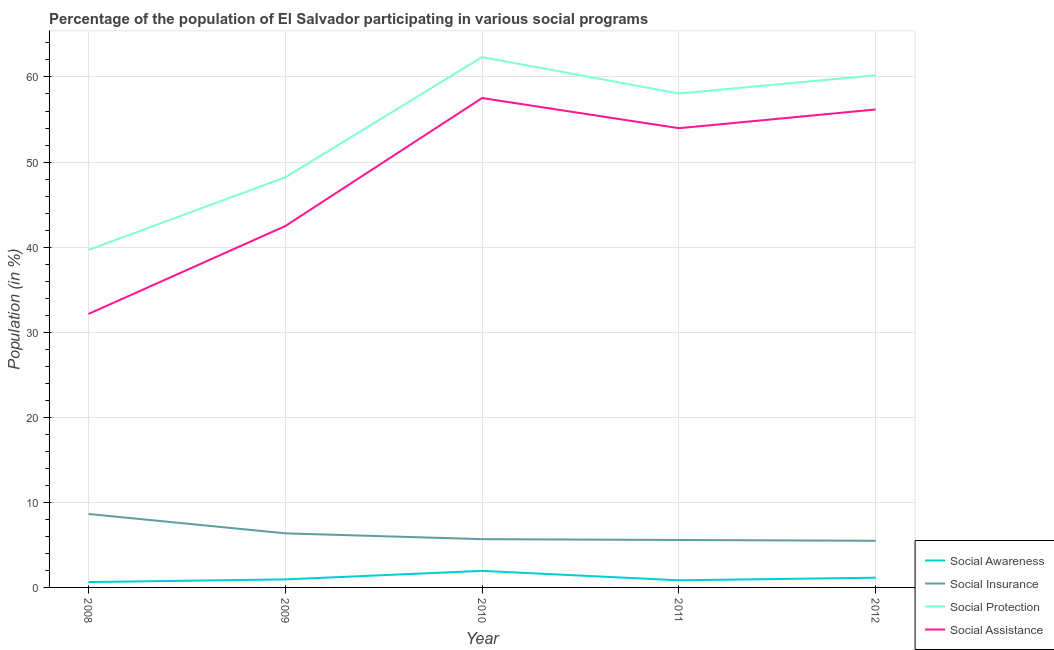Is the number of lines equal to the number of legend labels?
Keep it short and to the point. Yes. What is the participation of population in social assistance programs in 2012?
Offer a terse response. 56.18. Across all years, what is the maximum participation of population in social insurance programs?
Keep it short and to the point. 8.63. Across all years, what is the minimum participation of population in social awareness programs?
Your answer should be very brief. 0.63. In which year was the participation of population in social awareness programs maximum?
Make the answer very short. 2010. What is the total participation of population in social insurance programs in the graph?
Give a very brief answer. 31.72. What is the difference between the participation of population in social awareness programs in 2010 and that in 2011?
Offer a very short reply. 1.11. What is the difference between the participation of population in social insurance programs in 2011 and the participation of population in social protection programs in 2008?
Offer a terse response. -34.09. What is the average participation of population in social awareness programs per year?
Keep it short and to the point. 1.1. In the year 2010, what is the difference between the participation of population in social insurance programs and participation of population in social assistance programs?
Give a very brief answer. -51.85. In how many years, is the participation of population in social insurance programs greater than 8 %?
Make the answer very short. 1. What is the ratio of the participation of population in social insurance programs in 2009 to that in 2011?
Offer a terse response. 1.14. Is the participation of population in social awareness programs in 2009 less than that in 2012?
Ensure brevity in your answer.  Yes. Is the difference between the participation of population in social assistance programs in 2011 and 2012 greater than the difference between the participation of population in social insurance programs in 2011 and 2012?
Your answer should be very brief. No. What is the difference between the highest and the second highest participation of population in social awareness programs?
Provide a short and direct response. 0.8. What is the difference between the highest and the lowest participation of population in social protection programs?
Offer a very short reply. 22.67. In how many years, is the participation of population in social protection programs greater than the average participation of population in social protection programs taken over all years?
Provide a short and direct response. 3. Is it the case that in every year, the sum of the participation of population in social assistance programs and participation of population in social awareness programs is greater than the sum of participation of population in social protection programs and participation of population in social insurance programs?
Offer a very short reply. Yes. Does the participation of population in social assistance programs monotonically increase over the years?
Ensure brevity in your answer.  No. Does the graph contain grids?
Give a very brief answer. Yes. Where does the legend appear in the graph?
Your response must be concise. Bottom right. What is the title of the graph?
Give a very brief answer. Percentage of the population of El Salvador participating in various social programs . What is the label or title of the X-axis?
Offer a very short reply. Year. What is the Population (in %) in Social Awareness in 2008?
Your response must be concise. 0.63. What is the Population (in %) in Social Insurance in 2008?
Your response must be concise. 8.63. What is the Population (in %) in Social Protection in 2008?
Your response must be concise. 39.67. What is the Population (in %) of Social Assistance in 2008?
Provide a short and direct response. 32.15. What is the Population (in %) in Social Awareness in 2009?
Your answer should be compact. 0.95. What is the Population (in %) in Social Insurance in 2009?
Give a very brief answer. 6.36. What is the Population (in %) of Social Protection in 2009?
Make the answer very short. 48.2. What is the Population (in %) of Social Assistance in 2009?
Your response must be concise. 42.48. What is the Population (in %) of Social Awareness in 2010?
Give a very brief answer. 1.95. What is the Population (in %) of Social Insurance in 2010?
Offer a terse response. 5.67. What is the Population (in %) of Social Protection in 2010?
Give a very brief answer. 62.34. What is the Population (in %) in Social Assistance in 2010?
Make the answer very short. 57.53. What is the Population (in %) of Social Awareness in 2011?
Make the answer very short. 0.84. What is the Population (in %) in Social Insurance in 2011?
Give a very brief answer. 5.58. What is the Population (in %) of Social Protection in 2011?
Keep it short and to the point. 58.06. What is the Population (in %) in Social Assistance in 2011?
Offer a terse response. 53.98. What is the Population (in %) in Social Awareness in 2012?
Make the answer very short. 1.14. What is the Population (in %) of Social Insurance in 2012?
Provide a short and direct response. 5.48. What is the Population (in %) in Social Protection in 2012?
Provide a short and direct response. 60.19. What is the Population (in %) of Social Assistance in 2012?
Give a very brief answer. 56.18. Across all years, what is the maximum Population (in %) in Social Awareness?
Ensure brevity in your answer.  1.95. Across all years, what is the maximum Population (in %) in Social Insurance?
Keep it short and to the point. 8.63. Across all years, what is the maximum Population (in %) in Social Protection?
Your answer should be compact. 62.34. Across all years, what is the maximum Population (in %) of Social Assistance?
Ensure brevity in your answer.  57.53. Across all years, what is the minimum Population (in %) in Social Awareness?
Offer a very short reply. 0.63. Across all years, what is the minimum Population (in %) of Social Insurance?
Your answer should be compact. 5.48. Across all years, what is the minimum Population (in %) in Social Protection?
Provide a succinct answer. 39.67. Across all years, what is the minimum Population (in %) of Social Assistance?
Provide a short and direct response. 32.15. What is the total Population (in %) in Social Awareness in the graph?
Keep it short and to the point. 5.5. What is the total Population (in %) of Social Insurance in the graph?
Ensure brevity in your answer.  31.72. What is the total Population (in %) of Social Protection in the graph?
Your answer should be very brief. 268.46. What is the total Population (in %) of Social Assistance in the graph?
Offer a very short reply. 242.31. What is the difference between the Population (in %) in Social Awareness in 2008 and that in 2009?
Provide a succinct answer. -0.32. What is the difference between the Population (in %) in Social Insurance in 2008 and that in 2009?
Make the answer very short. 2.28. What is the difference between the Population (in %) of Social Protection in 2008 and that in 2009?
Provide a succinct answer. -8.53. What is the difference between the Population (in %) of Social Assistance in 2008 and that in 2009?
Offer a terse response. -10.33. What is the difference between the Population (in %) in Social Awareness in 2008 and that in 2010?
Offer a very short reply. -1.32. What is the difference between the Population (in %) in Social Insurance in 2008 and that in 2010?
Make the answer very short. 2.96. What is the difference between the Population (in %) of Social Protection in 2008 and that in 2010?
Ensure brevity in your answer.  -22.67. What is the difference between the Population (in %) of Social Assistance in 2008 and that in 2010?
Your response must be concise. -25.38. What is the difference between the Population (in %) in Social Awareness in 2008 and that in 2011?
Keep it short and to the point. -0.21. What is the difference between the Population (in %) of Social Insurance in 2008 and that in 2011?
Your answer should be very brief. 3.06. What is the difference between the Population (in %) in Social Protection in 2008 and that in 2011?
Your answer should be very brief. -18.39. What is the difference between the Population (in %) of Social Assistance in 2008 and that in 2011?
Your answer should be very brief. -21.83. What is the difference between the Population (in %) in Social Awareness in 2008 and that in 2012?
Your response must be concise. -0.51. What is the difference between the Population (in %) of Social Insurance in 2008 and that in 2012?
Your answer should be very brief. 3.15. What is the difference between the Population (in %) in Social Protection in 2008 and that in 2012?
Provide a short and direct response. -20.53. What is the difference between the Population (in %) of Social Assistance in 2008 and that in 2012?
Your answer should be compact. -24.03. What is the difference between the Population (in %) in Social Awareness in 2009 and that in 2010?
Your answer should be compact. -1. What is the difference between the Population (in %) in Social Insurance in 2009 and that in 2010?
Your answer should be very brief. 0.68. What is the difference between the Population (in %) of Social Protection in 2009 and that in 2010?
Provide a short and direct response. -14.14. What is the difference between the Population (in %) in Social Assistance in 2009 and that in 2010?
Your answer should be very brief. -15.05. What is the difference between the Population (in %) of Social Awareness in 2009 and that in 2011?
Provide a succinct answer. 0.11. What is the difference between the Population (in %) of Social Insurance in 2009 and that in 2011?
Your answer should be compact. 0.78. What is the difference between the Population (in %) of Social Protection in 2009 and that in 2011?
Give a very brief answer. -9.86. What is the difference between the Population (in %) of Social Assistance in 2009 and that in 2011?
Your answer should be very brief. -11.5. What is the difference between the Population (in %) in Social Awareness in 2009 and that in 2012?
Provide a succinct answer. -0.2. What is the difference between the Population (in %) in Social Insurance in 2009 and that in 2012?
Offer a very short reply. 0.88. What is the difference between the Population (in %) in Social Protection in 2009 and that in 2012?
Keep it short and to the point. -11.99. What is the difference between the Population (in %) in Social Assistance in 2009 and that in 2012?
Provide a short and direct response. -13.7. What is the difference between the Population (in %) in Social Awareness in 2010 and that in 2011?
Your answer should be very brief. 1.11. What is the difference between the Population (in %) in Social Insurance in 2010 and that in 2011?
Make the answer very short. 0.1. What is the difference between the Population (in %) of Social Protection in 2010 and that in 2011?
Make the answer very short. 4.28. What is the difference between the Population (in %) of Social Assistance in 2010 and that in 2011?
Your response must be concise. 3.55. What is the difference between the Population (in %) in Social Awareness in 2010 and that in 2012?
Provide a short and direct response. 0.8. What is the difference between the Population (in %) of Social Insurance in 2010 and that in 2012?
Provide a succinct answer. 0.19. What is the difference between the Population (in %) of Social Protection in 2010 and that in 2012?
Provide a short and direct response. 2.15. What is the difference between the Population (in %) of Social Assistance in 2010 and that in 2012?
Provide a succinct answer. 1.34. What is the difference between the Population (in %) of Social Awareness in 2011 and that in 2012?
Give a very brief answer. -0.3. What is the difference between the Population (in %) of Social Insurance in 2011 and that in 2012?
Your answer should be compact. 0.09. What is the difference between the Population (in %) in Social Protection in 2011 and that in 2012?
Your answer should be compact. -2.14. What is the difference between the Population (in %) of Social Assistance in 2011 and that in 2012?
Keep it short and to the point. -2.2. What is the difference between the Population (in %) in Social Awareness in 2008 and the Population (in %) in Social Insurance in 2009?
Keep it short and to the point. -5.73. What is the difference between the Population (in %) in Social Awareness in 2008 and the Population (in %) in Social Protection in 2009?
Your answer should be very brief. -47.57. What is the difference between the Population (in %) in Social Awareness in 2008 and the Population (in %) in Social Assistance in 2009?
Provide a succinct answer. -41.85. What is the difference between the Population (in %) in Social Insurance in 2008 and the Population (in %) in Social Protection in 2009?
Your answer should be very brief. -39.57. What is the difference between the Population (in %) of Social Insurance in 2008 and the Population (in %) of Social Assistance in 2009?
Make the answer very short. -33.84. What is the difference between the Population (in %) in Social Protection in 2008 and the Population (in %) in Social Assistance in 2009?
Give a very brief answer. -2.81. What is the difference between the Population (in %) in Social Awareness in 2008 and the Population (in %) in Social Insurance in 2010?
Ensure brevity in your answer.  -5.04. What is the difference between the Population (in %) of Social Awareness in 2008 and the Population (in %) of Social Protection in 2010?
Ensure brevity in your answer.  -61.71. What is the difference between the Population (in %) in Social Awareness in 2008 and the Population (in %) in Social Assistance in 2010?
Ensure brevity in your answer.  -56.9. What is the difference between the Population (in %) in Social Insurance in 2008 and the Population (in %) in Social Protection in 2010?
Your answer should be compact. -53.71. What is the difference between the Population (in %) of Social Insurance in 2008 and the Population (in %) of Social Assistance in 2010?
Offer a very short reply. -48.89. What is the difference between the Population (in %) in Social Protection in 2008 and the Population (in %) in Social Assistance in 2010?
Provide a succinct answer. -17.86. What is the difference between the Population (in %) in Social Awareness in 2008 and the Population (in %) in Social Insurance in 2011?
Provide a succinct answer. -4.95. What is the difference between the Population (in %) in Social Awareness in 2008 and the Population (in %) in Social Protection in 2011?
Ensure brevity in your answer.  -57.43. What is the difference between the Population (in %) in Social Awareness in 2008 and the Population (in %) in Social Assistance in 2011?
Offer a terse response. -53.35. What is the difference between the Population (in %) in Social Insurance in 2008 and the Population (in %) in Social Protection in 2011?
Your answer should be compact. -49.42. What is the difference between the Population (in %) in Social Insurance in 2008 and the Population (in %) in Social Assistance in 2011?
Your answer should be very brief. -45.34. What is the difference between the Population (in %) of Social Protection in 2008 and the Population (in %) of Social Assistance in 2011?
Your answer should be compact. -14.31. What is the difference between the Population (in %) of Social Awareness in 2008 and the Population (in %) of Social Insurance in 2012?
Provide a succinct answer. -4.85. What is the difference between the Population (in %) of Social Awareness in 2008 and the Population (in %) of Social Protection in 2012?
Keep it short and to the point. -59.57. What is the difference between the Population (in %) of Social Awareness in 2008 and the Population (in %) of Social Assistance in 2012?
Provide a short and direct response. -55.55. What is the difference between the Population (in %) of Social Insurance in 2008 and the Population (in %) of Social Protection in 2012?
Make the answer very short. -51.56. What is the difference between the Population (in %) in Social Insurance in 2008 and the Population (in %) in Social Assistance in 2012?
Offer a terse response. -47.55. What is the difference between the Population (in %) in Social Protection in 2008 and the Population (in %) in Social Assistance in 2012?
Provide a succinct answer. -16.51. What is the difference between the Population (in %) in Social Awareness in 2009 and the Population (in %) in Social Insurance in 2010?
Keep it short and to the point. -4.73. What is the difference between the Population (in %) in Social Awareness in 2009 and the Population (in %) in Social Protection in 2010?
Provide a succinct answer. -61.4. What is the difference between the Population (in %) of Social Awareness in 2009 and the Population (in %) of Social Assistance in 2010?
Make the answer very short. -56.58. What is the difference between the Population (in %) of Social Insurance in 2009 and the Population (in %) of Social Protection in 2010?
Offer a terse response. -55.98. What is the difference between the Population (in %) of Social Insurance in 2009 and the Population (in %) of Social Assistance in 2010?
Provide a succinct answer. -51.17. What is the difference between the Population (in %) in Social Protection in 2009 and the Population (in %) in Social Assistance in 2010?
Your response must be concise. -9.32. What is the difference between the Population (in %) in Social Awareness in 2009 and the Population (in %) in Social Insurance in 2011?
Provide a succinct answer. -4.63. What is the difference between the Population (in %) in Social Awareness in 2009 and the Population (in %) in Social Protection in 2011?
Your response must be concise. -57.11. What is the difference between the Population (in %) of Social Awareness in 2009 and the Population (in %) of Social Assistance in 2011?
Ensure brevity in your answer.  -53.03. What is the difference between the Population (in %) of Social Insurance in 2009 and the Population (in %) of Social Protection in 2011?
Make the answer very short. -51.7. What is the difference between the Population (in %) in Social Insurance in 2009 and the Population (in %) in Social Assistance in 2011?
Your response must be concise. -47.62. What is the difference between the Population (in %) in Social Protection in 2009 and the Population (in %) in Social Assistance in 2011?
Make the answer very short. -5.78. What is the difference between the Population (in %) in Social Awareness in 2009 and the Population (in %) in Social Insurance in 2012?
Provide a short and direct response. -4.54. What is the difference between the Population (in %) of Social Awareness in 2009 and the Population (in %) of Social Protection in 2012?
Make the answer very short. -59.25. What is the difference between the Population (in %) in Social Awareness in 2009 and the Population (in %) in Social Assistance in 2012?
Offer a very short reply. -55.24. What is the difference between the Population (in %) in Social Insurance in 2009 and the Population (in %) in Social Protection in 2012?
Your answer should be compact. -53.84. What is the difference between the Population (in %) of Social Insurance in 2009 and the Population (in %) of Social Assistance in 2012?
Make the answer very short. -49.82. What is the difference between the Population (in %) in Social Protection in 2009 and the Population (in %) in Social Assistance in 2012?
Make the answer very short. -7.98. What is the difference between the Population (in %) of Social Awareness in 2010 and the Population (in %) of Social Insurance in 2011?
Provide a short and direct response. -3.63. What is the difference between the Population (in %) of Social Awareness in 2010 and the Population (in %) of Social Protection in 2011?
Make the answer very short. -56.11. What is the difference between the Population (in %) of Social Awareness in 2010 and the Population (in %) of Social Assistance in 2011?
Keep it short and to the point. -52.03. What is the difference between the Population (in %) of Social Insurance in 2010 and the Population (in %) of Social Protection in 2011?
Ensure brevity in your answer.  -52.38. What is the difference between the Population (in %) in Social Insurance in 2010 and the Population (in %) in Social Assistance in 2011?
Your answer should be compact. -48.31. What is the difference between the Population (in %) in Social Protection in 2010 and the Population (in %) in Social Assistance in 2011?
Your answer should be very brief. 8.36. What is the difference between the Population (in %) of Social Awareness in 2010 and the Population (in %) of Social Insurance in 2012?
Provide a short and direct response. -3.54. What is the difference between the Population (in %) in Social Awareness in 2010 and the Population (in %) in Social Protection in 2012?
Make the answer very short. -58.25. What is the difference between the Population (in %) of Social Awareness in 2010 and the Population (in %) of Social Assistance in 2012?
Make the answer very short. -54.24. What is the difference between the Population (in %) of Social Insurance in 2010 and the Population (in %) of Social Protection in 2012?
Make the answer very short. -54.52. What is the difference between the Population (in %) in Social Insurance in 2010 and the Population (in %) in Social Assistance in 2012?
Make the answer very short. -50.51. What is the difference between the Population (in %) in Social Protection in 2010 and the Population (in %) in Social Assistance in 2012?
Offer a terse response. 6.16. What is the difference between the Population (in %) in Social Awareness in 2011 and the Population (in %) in Social Insurance in 2012?
Provide a succinct answer. -4.65. What is the difference between the Population (in %) of Social Awareness in 2011 and the Population (in %) of Social Protection in 2012?
Make the answer very short. -59.36. What is the difference between the Population (in %) of Social Awareness in 2011 and the Population (in %) of Social Assistance in 2012?
Provide a short and direct response. -55.34. What is the difference between the Population (in %) of Social Insurance in 2011 and the Population (in %) of Social Protection in 2012?
Make the answer very short. -54.62. What is the difference between the Population (in %) of Social Insurance in 2011 and the Population (in %) of Social Assistance in 2012?
Provide a succinct answer. -50.6. What is the difference between the Population (in %) in Social Protection in 2011 and the Population (in %) in Social Assistance in 2012?
Make the answer very short. 1.88. What is the average Population (in %) in Social Awareness per year?
Keep it short and to the point. 1.1. What is the average Population (in %) of Social Insurance per year?
Provide a short and direct response. 6.34. What is the average Population (in %) in Social Protection per year?
Ensure brevity in your answer.  53.69. What is the average Population (in %) of Social Assistance per year?
Offer a terse response. 48.46. In the year 2008, what is the difference between the Population (in %) of Social Awareness and Population (in %) of Social Insurance?
Ensure brevity in your answer.  -8.01. In the year 2008, what is the difference between the Population (in %) in Social Awareness and Population (in %) in Social Protection?
Offer a terse response. -39.04. In the year 2008, what is the difference between the Population (in %) in Social Awareness and Population (in %) in Social Assistance?
Make the answer very short. -31.52. In the year 2008, what is the difference between the Population (in %) in Social Insurance and Population (in %) in Social Protection?
Your response must be concise. -31.03. In the year 2008, what is the difference between the Population (in %) of Social Insurance and Population (in %) of Social Assistance?
Your answer should be very brief. -23.51. In the year 2008, what is the difference between the Population (in %) in Social Protection and Population (in %) in Social Assistance?
Your response must be concise. 7.52. In the year 2009, what is the difference between the Population (in %) in Social Awareness and Population (in %) in Social Insurance?
Make the answer very short. -5.41. In the year 2009, what is the difference between the Population (in %) in Social Awareness and Population (in %) in Social Protection?
Keep it short and to the point. -47.26. In the year 2009, what is the difference between the Population (in %) of Social Awareness and Population (in %) of Social Assistance?
Keep it short and to the point. -41.53. In the year 2009, what is the difference between the Population (in %) in Social Insurance and Population (in %) in Social Protection?
Your answer should be compact. -41.84. In the year 2009, what is the difference between the Population (in %) in Social Insurance and Population (in %) in Social Assistance?
Your answer should be very brief. -36.12. In the year 2009, what is the difference between the Population (in %) in Social Protection and Population (in %) in Social Assistance?
Your answer should be compact. 5.72. In the year 2010, what is the difference between the Population (in %) in Social Awareness and Population (in %) in Social Insurance?
Offer a terse response. -3.73. In the year 2010, what is the difference between the Population (in %) of Social Awareness and Population (in %) of Social Protection?
Keep it short and to the point. -60.39. In the year 2010, what is the difference between the Population (in %) in Social Awareness and Population (in %) in Social Assistance?
Offer a very short reply. -55.58. In the year 2010, what is the difference between the Population (in %) in Social Insurance and Population (in %) in Social Protection?
Your answer should be compact. -56.67. In the year 2010, what is the difference between the Population (in %) of Social Insurance and Population (in %) of Social Assistance?
Your answer should be compact. -51.85. In the year 2010, what is the difference between the Population (in %) in Social Protection and Population (in %) in Social Assistance?
Give a very brief answer. 4.82. In the year 2011, what is the difference between the Population (in %) in Social Awareness and Population (in %) in Social Insurance?
Provide a short and direct response. -4.74. In the year 2011, what is the difference between the Population (in %) in Social Awareness and Population (in %) in Social Protection?
Provide a succinct answer. -57.22. In the year 2011, what is the difference between the Population (in %) of Social Awareness and Population (in %) of Social Assistance?
Ensure brevity in your answer.  -53.14. In the year 2011, what is the difference between the Population (in %) of Social Insurance and Population (in %) of Social Protection?
Give a very brief answer. -52.48. In the year 2011, what is the difference between the Population (in %) of Social Insurance and Population (in %) of Social Assistance?
Make the answer very short. -48.4. In the year 2011, what is the difference between the Population (in %) of Social Protection and Population (in %) of Social Assistance?
Your answer should be compact. 4.08. In the year 2012, what is the difference between the Population (in %) of Social Awareness and Population (in %) of Social Insurance?
Ensure brevity in your answer.  -4.34. In the year 2012, what is the difference between the Population (in %) of Social Awareness and Population (in %) of Social Protection?
Your answer should be compact. -59.05. In the year 2012, what is the difference between the Population (in %) in Social Awareness and Population (in %) in Social Assistance?
Offer a very short reply. -55.04. In the year 2012, what is the difference between the Population (in %) of Social Insurance and Population (in %) of Social Protection?
Your answer should be very brief. -54.71. In the year 2012, what is the difference between the Population (in %) of Social Insurance and Population (in %) of Social Assistance?
Offer a very short reply. -50.7. In the year 2012, what is the difference between the Population (in %) in Social Protection and Population (in %) in Social Assistance?
Ensure brevity in your answer.  4.01. What is the ratio of the Population (in %) in Social Awareness in 2008 to that in 2009?
Your answer should be compact. 0.67. What is the ratio of the Population (in %) in Social Insurance in 2008 to that in 2009?
Your answer should be compact. 1.36. What is the ratio of the Population (in %) in Social Protection in 2008 to that in 2009?
Ensure brevity in your answer.  0.82. What is the ratio of the Population (in %) of Social Assistance in 2008 to that in 2009?
Your answer should be very brief. 0.76. What is the ratio of the Population (in %) in Social Awareness in 2008 to that in 2010?
Provide a short and direct response. 0.32. What is the ratio of the Population (in %) in Social Insurance in 2008 to that in 2010?
Give a very brief answer. 1.52. What is the ratio of the Population (in %) of Social Protection in 2008 to that in 2010?
Ensure brevity in your answer.  0.64. What is the ratio of the Population (in %) of Social Assistance in 2008 to that in 2010?
Give a very brief answer. 0.56. What is the ratio of the Population (in %) of Social Awareness in 2008 to that in 2011?
Your answer should be compact. 0.75. What is the ratio of the Population (in %) of Social Insurance in 2008 to that in 2011?
Provide a short and direct response. 1.55. What is the ratio of the Population (in %) in Social Protection in 2008 to that in 2011?
Make the answer very short. 0.68. What is the ratio of the Population (in %) in Social Assistance in 2008 to that in 2011?
Ensure brevity in your answer.  0.6. What is the ratio of the Population (in %) of Social Awareness in 2008 to that in 2012?
Your answer should be very brief. 0.55. What is the ratio of the Population (in %) in Social Insurance in 2008 to that in 2012?
Provide a succinct answer. 1.57. What is the ratio of the Population (in %) of Social Protection in 2008 to that in 2012?
Provide a short and direct response. 0.66. What is the ratio of the Population (in %) in Social Assistance in 2008 to that in 2012?
Your answer should be very brief. 0.57. What is the ratio of the Population (in %) of Social Awareness in 2009 to that in 2010?
Provide a succinct answer. 0.49. What is the ratio of the Population (in %) in Social Insurance in 2009 to that in 2010?
Make the answer very short. 1.12. What is the ratio of the Population (in %) of Social Protection in 2009 to that in 2010?
Your answer should be compact. 0.77. What is the ratio of the Population (in %) of Social Assistance in 2009 to that in 2010?
Provide a short and direct response. 0.74. What is the ratio of the Population (in %) of Social Awareness in 2009 to that in 2011?
Provide a succinct answer. 1.13. What is the ratio of the Population (in %) in Social Insurance in 2009 to that in 2011?
Ensure brevity in your answer.  1.14. What is the ratio of the Population (in %) of Social Protection in 2009 to that in 2011?
Your response must be concise. 0.83. What is the ratio of the Population (in %) in Social Assistance in 2009 to that in 2011?
Your response must be concise. 0.79. What is the ratio of the Population (in %) in Social Awareness in 2009 to that in 2012?
Offer a terse response. 0.83. What is the ratio of the Population (in %) in Social Insurance in 2009 to that in 2012?
Offer a very short reply. 1.16. What is the ratio of the Population (in %) in Social Protection in 2009 to that in 2012?
Make the answer very short. 0.8. What is the ratio of the Population (in %) in Social Assistance in 2009 to that in 2012?
Your answer should be compact. 0.76. What is the ratio of the Population (in %) in Social Awareness in 2010 to that in 2011?
Your response must be concise. 2.32. What is the ratio of the Population (in %) in Social Insurance in 2010 to that in 2011?
Provide a short and direct response. 1.02. What is the ratio of the Population (in %) of Social Protection in 2010 to that in 2011?
Provide a short and direct response. 1.07. What is the ratio of the Population (in %) of Social Assistance in 2010 to that in 2011?
Provide a short and direct response. 1.07. What is the ratio of the Population (in %) in Social Awareness in 2010 to that in 2012?
Your response must be concise. 1.71. What is the ratio of the Population (in %) in Social Insurance in 2010 to that in 2012?
Offer a terse response. 1.03. What is the ratio of the Population (in %) in Social Protection in 2010 to that in 2012?
Your response must be concise. 1.04. What is the ratio of the Population (in %) in Social Assistance in 2010 to that in 2012?
Give a very brief answer. 1.02. What is the ratio of the Population (in %) in Social Awareness in 2011 to that in 2012?
Give a very brief answer. 0.73. What is the ratio of the Population (in %) in Social Insurance in 2011 to that in 2012?
Give a very brief answer. 1.02. What is the ratio of the Population (in %) in Social Protection in 2011 to that in 2012?
Give a very brief answer. 0.96. What is the ratio of the Population (in %) in Social Assistance in 2011 to that in 2012?
Ensure brevity in your answer.  0.96. What is the difference between the highest and the second highest Population (in %) of Social Awareness?
Give a very brief answer. 0.8. What is the difference between the highest and the second highest Population (in %) in Social Insurance?
Provide a short and direct response. 2.28. What is the difference between the highest and the second highest Population (in %) of Social Protection?
Your answer should be compact. 2.15. What is the difference between the highest and the second highest Population (in %) of Social Assistance?
Offer a terse response. 1.34. What is the difference between the highest and the lowest Population (in %) in Social Awareness?
Offer a terse response. 1.32. What is the difference between the highest and the lowest Population (in %) in Social Insurance?
Offer a terse response. 3.15. What is the difference between the highest and the lowest Population (in %) in Social Protection?
Offer a very short reply. 22.67. What is the difference between the highest and the lowest Population (in %) in Social Assistance?
Offer a very short reply. 25.38. 